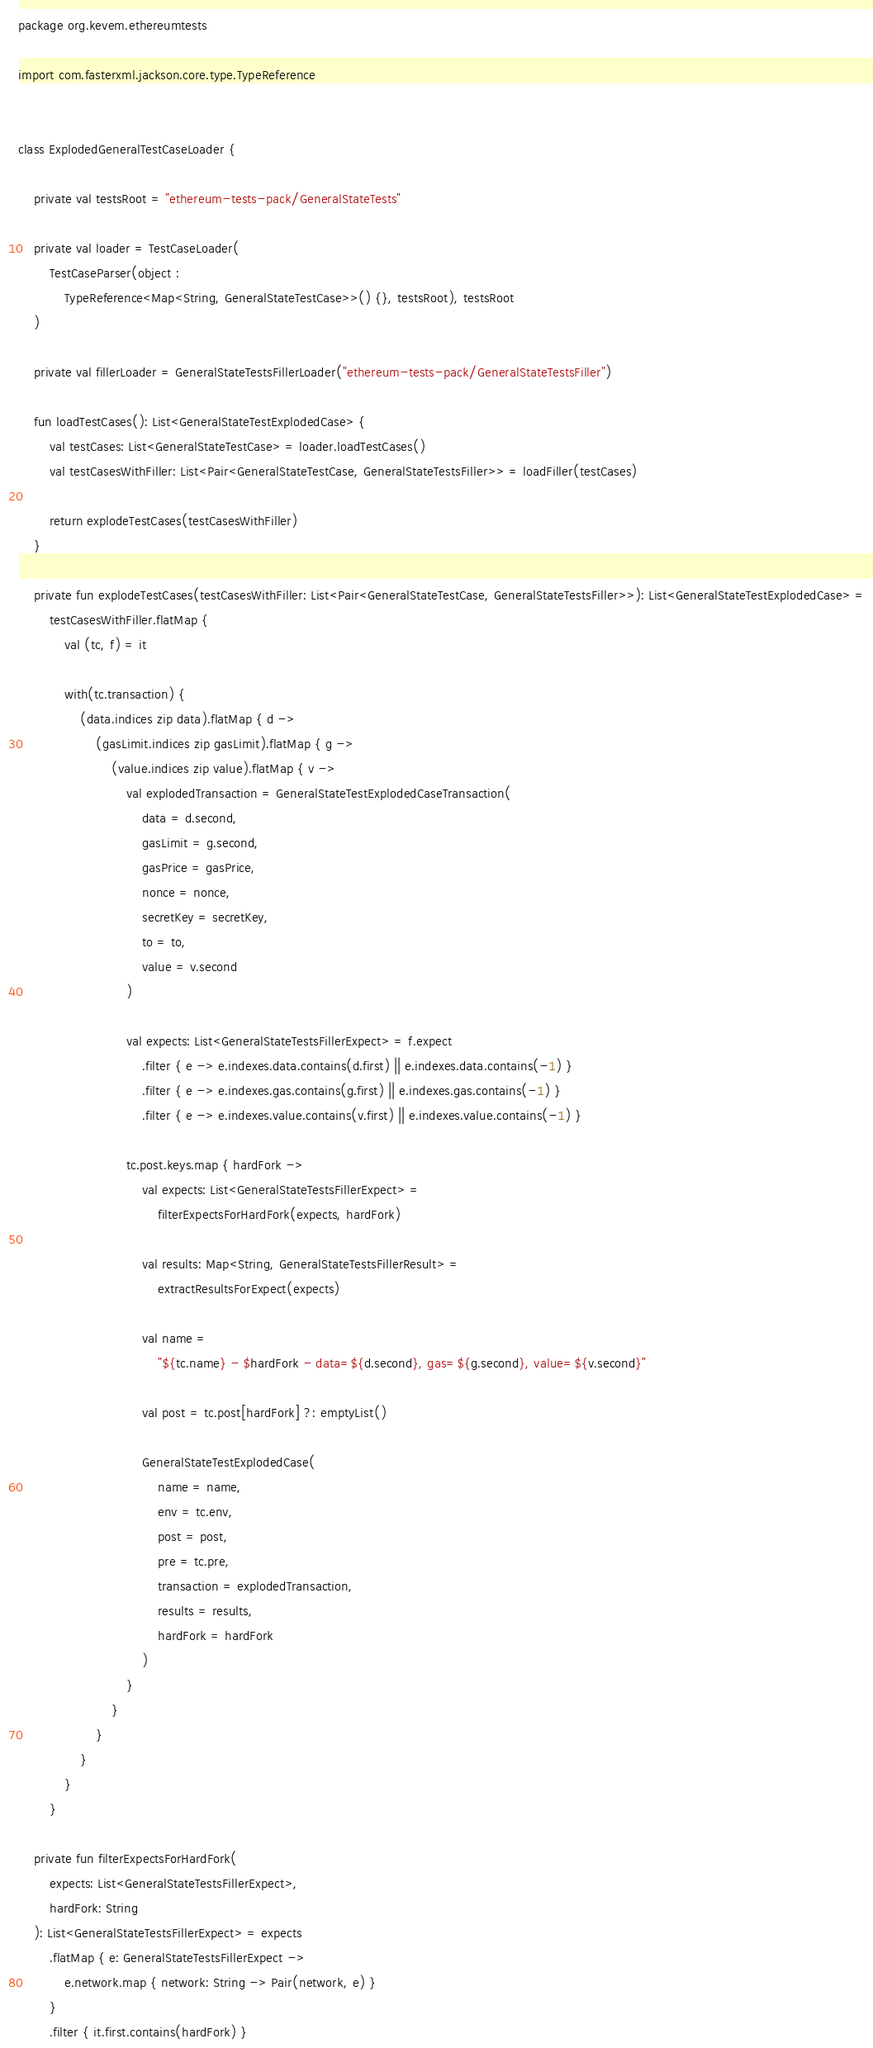Convert code to text. <code><loc_0><loc_0><loc_500><loc_500><_Kotlin_>package org.kevem.ethereumtests

import com.fasterxml.jackson.core.type.TypeReference


class ExplodedGeneralTestCaseLoader {

    private val testsRoot = "ethereum-tests-pack/GeneralStateTests"

    private val loader = TestCaseLoader(
        TestCaseParser(object :
            TypeReference<Map<String, GeneralStateTestCase>>() {}, testsRoot), testsRoot
    )

    private val fillerLoader = GeneralStateTestsFillerLoader("ethereum-tests-pack/GeneralStateTestsFiller")

    fun loadTestCases(): List<GeneralStateTestExplodedCase> {
        val testCases: List<GeneralStateTestCase> = loader.loadTestCases()
        val testCasesWithFiller: List<Pair<GeneralStateTestCase, GeneralStateTestsFiller>> = loadFiller(testCases)

        return explodeTestCases(testCasesWithFiller)
    }

    private fun explodeTestCases(testCasesWithFiller: List<Pair<GeneralStateTestCase, GeneralStateTestsFiller>>): List<GeneralStateTestExplodedCase> =
        testCasesWithFiller.flatMap {
            val (tc, f) = it

            with(tc.transaction) {
                (data.indices zip data).flatMap { d ->
                    (gasLimit.indices zip gasLimit).flatMap { g ->
                        (value.indices zip value).flatMap { v ->
                            val explodedTransaction = GeneralStateTestExplodedCaseTransaction(
                                data = d.second,
                                gasLimit = g.second,
                                gasPrice = gasPrice,
                                nonce = nonce,
                                secretKey = secretKey,
                                to = to,
                                value = v.second
                            )

                            val expects: List<GeneralStateTestsFillerExpect> = f.expect
                                .filter { e -> e.indexes.data.contains(d.first) || e.indexes.data.contains(-1) }
                                .filter { e -> e.indexes.gas.contains(g.first) || e.indexes.gas.contains(-1) }
                                .filter { e -> e.indexes.value.contains(v.first) || e.indexes.value.contains(-1) }

                            tc.post.keys.map { hardFork ->
                                val expects: List<GeneralStateTestsFillerExpect> =
                                    filterExpectsForHardFork(expects, hardFork)

                                val results: Map<String, GeneralStateTestsFillerResult> =
                                    extractResultsForExpect(expects)

                                val name =
                                    "${tc.name} - $hardFork - data=${d.second}, gas=${g.second}, value=${v.second}"

                                val post = tc.post[hardFork] ?: emptyList()

                                GeneralStateTestExplodedCase(
                                    name = name,
                                    env = tc.env,
                                    post = post,
                                    pre = tc.pre,
                                    transaction = explodedTransaction,
                                    results = results,
                                    hardFork = hardFork
                                )
                            }
                        }
                    }
                }
            }
        }

    private fun filterExpectsForHardFork(
        expects: List<GeneralStateTestsFillerExpect>,
        hardFork: String
    ): List<GeneralStateTestsFillerExpect> = expects
        .flatMap { e: GeneralStateTestsFillerExpect ->
            e.network.map { network: String -> Pair(network, e) }
        }
        .filter { it.first.contains(hardFork) }</code> 